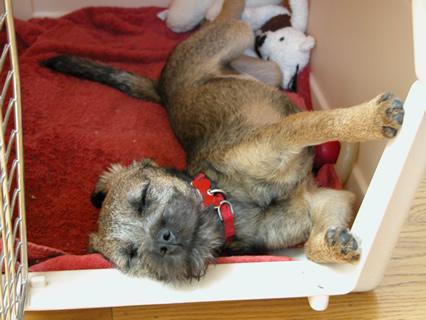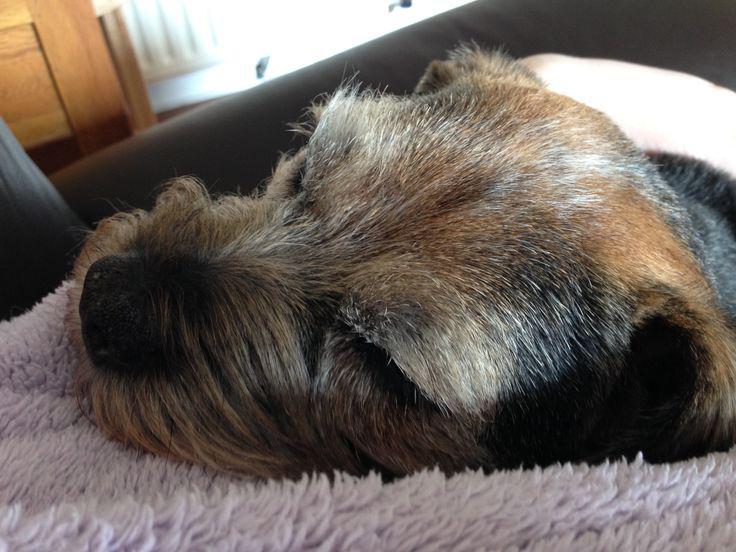The first image is the image on the left, the second image is the image on the right. For the images shown, is this caption "One dog is sleeping on a piece of furniture with its head resting against a squarish patterned pillow." true? Answer yes or no. No. The first image is the image on the left, the second image is the image on the right. Assess this claim about the two images: "At least one dog is sleeping on a throw pillow.". Correct or not? Answer yes or no. No. 